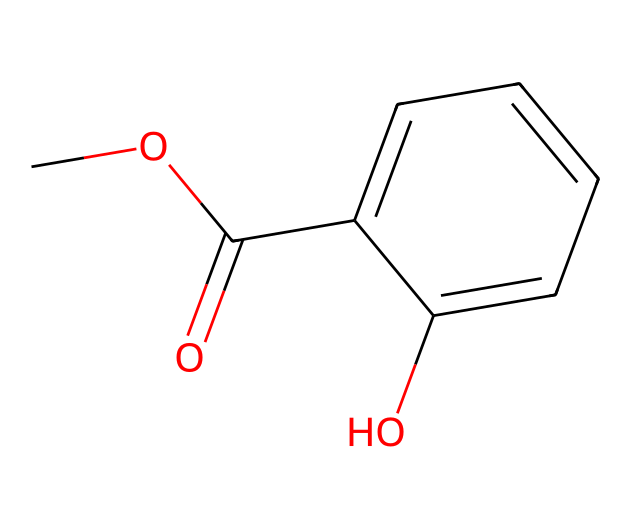What is the primary functional group in this compound? The compound features an ester functional group, indicated by the -COOC- structure attached to a phenolic ring. The structure contains a carbonyl (C=O) and an alkoxy (-O-) part, characteristic of esters.
Answer: ester How many rings are present in the structure? The structural formula shows one six-membered cyclic system, which is the benzene ring. There are no additional rings shown in the structure.
Answer: one What type of aromatic compound is evident in this structure? The compound contains a phenolic portion due to the presence of a hydroxyl group (-OH) directly attached to the benzene ring. This feature classifies it as a phenol.
Answer: phenol What is the total number of carbon atoms in the chemical? Counting the carbon atoms in the hydrocarbon skeleton, there are a total of 10 carbon atoms present in this compound: 6 from the benzene ring and 4 from the side chain including the ester group.
Answer: ten Which part of this structure is responsible for the analgesic properties? The ester moiety generally contributes to analgesic properties in topical applications, interacting with pain receptors and providing relief. This is often seen in muscle rubs and pain relief creams.
Answer: ester moiety Does this compound contain any heteroatoms? Yes, the structure contains an oxygen atom in the ester functional group and another in the hydroxyl group, qualifying it as a compound with heteroatoms.
Answer: yes 